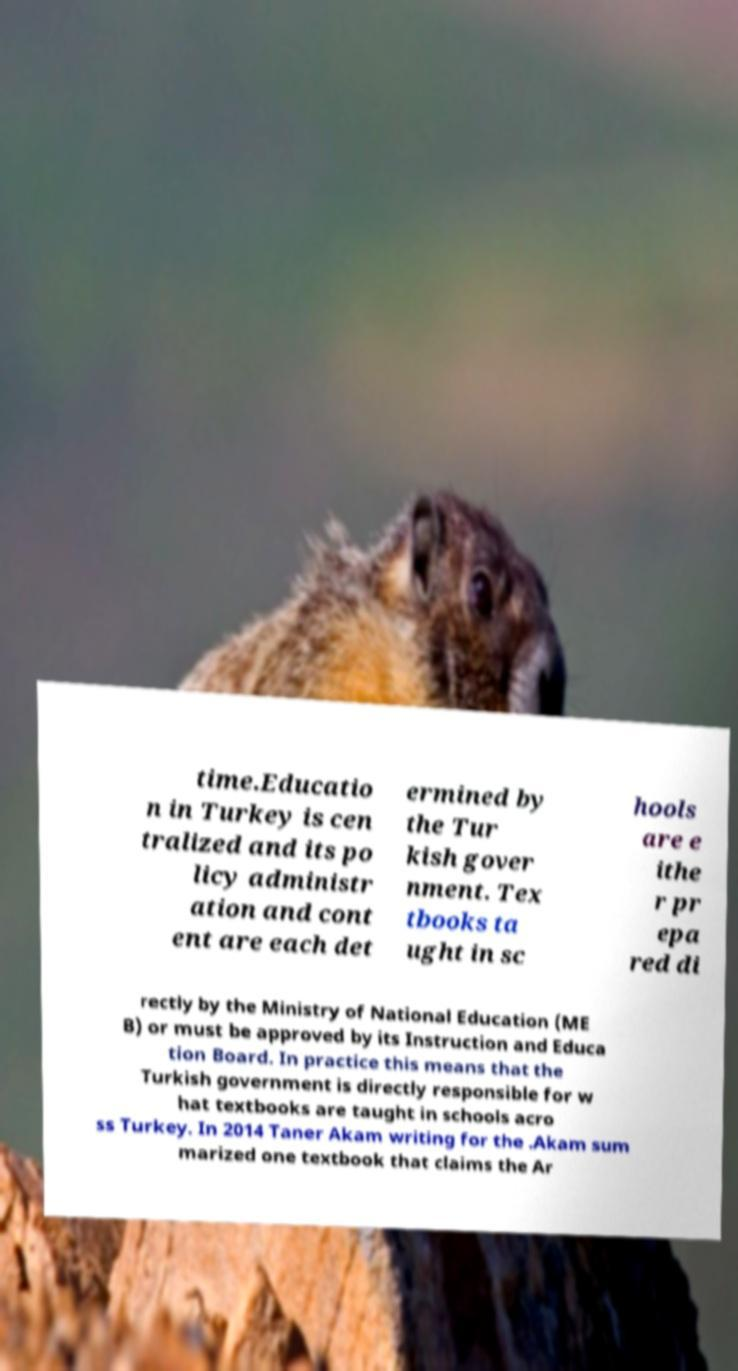There's text embedded in this image that I need extracted. Can you transcribe it verbatim? time.Educatio n in Turkey is cen tralized and its po licy administr ation and cont ent are each det ermined by the Tur kish gover nment. Tex tbooks ta ught in sc hools are e ithe r pr epa red di rectly by the Ministry of National Education (ME B) or must be approved by its Instruction and Educa tion Board. In practice this means that the Turkish government is directly responsible for w hat textbooks are taught in schools acro ss Turkey. In 2014 Taner Akam writing for the .Akam sum marized one textbook that claims the Ar 